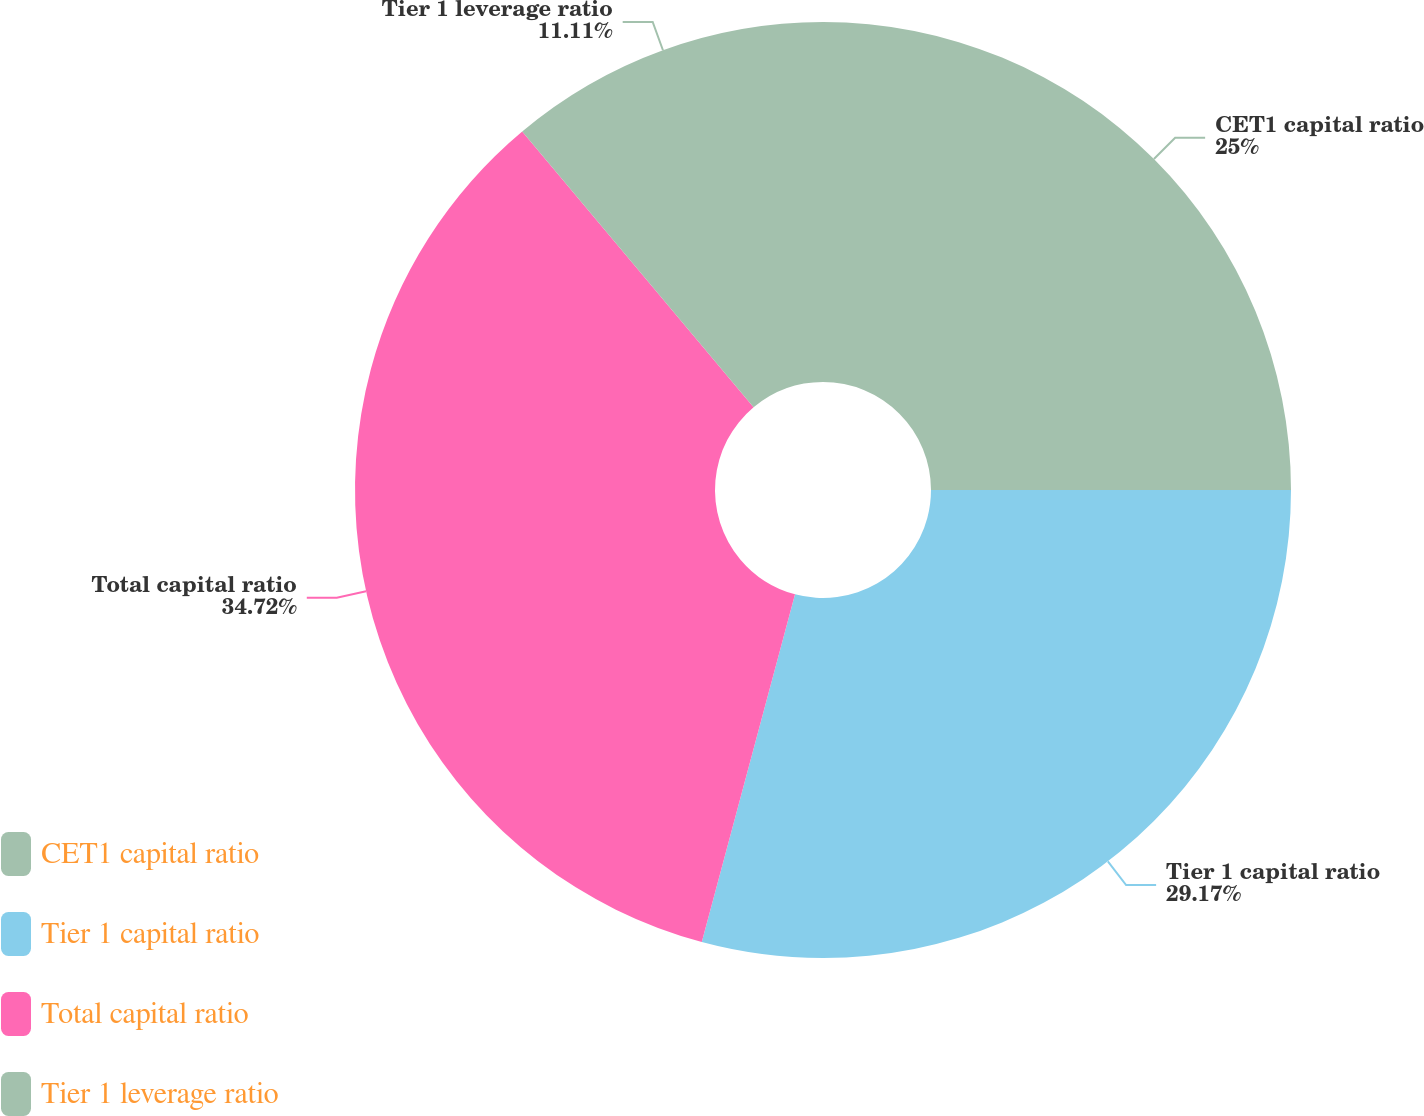<chart> <loc_0><loc_0><loc_500><loc_500><pie_chart><fcel>CET1 capital ratio<fcel>Tier 1 capital ratio<fcel>Total capital ratio<fcel>Tier 1 leverage ratio<nl><fcel>25.0%<fcel>29.17%<fcel>34.72%<fcel>11.11%<nl></chart> 